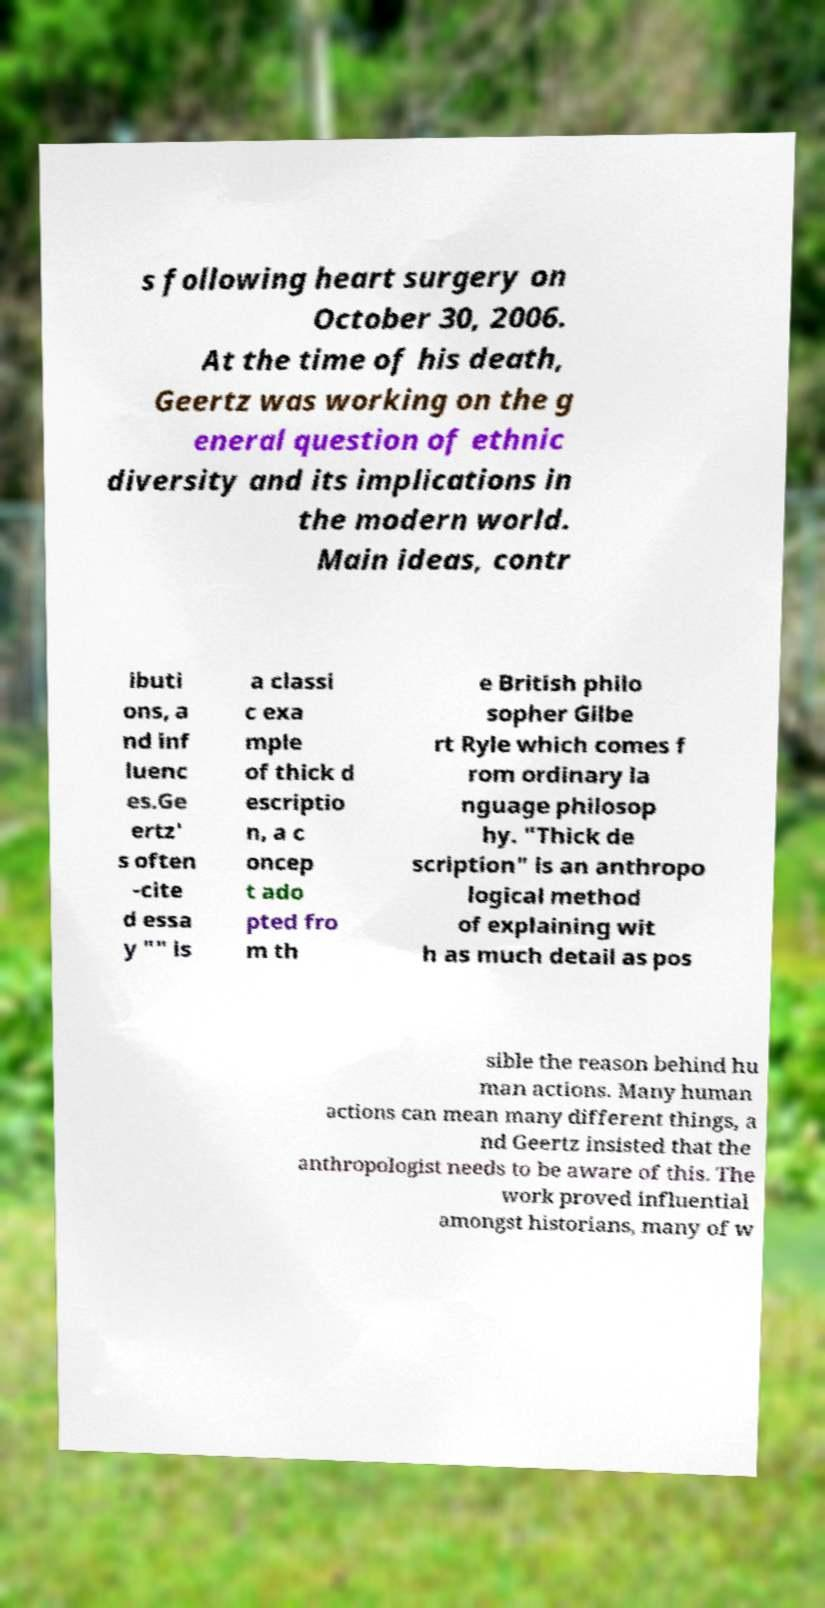Please read and relay the text visible in this image. What does it say? s following heart surgery on October 30, 2006. At the time of his death, Geertz was working on the g eneral question of ethnic diversity and its implications in the modern world. Main ideas, contr ibuti ons, a nd inf luenc es.Ge ertz' s often -cite d essa y "" is a classi c exa mple of thick d escriptio n, a c oncep t ado pted fro m th e British philo sopher Gilbe rt Ryle which comes f rom ordinary la nguage philosop hy. "Thick de scription" is an anthropo logical method of explaining wit h as much detail as pos sible the reason behind hu man actions. Many human actions can mean many different things, a nd Geertz insisted that the anthropologist needs to be aware of this. The work proved influential amongst historians, many of w 